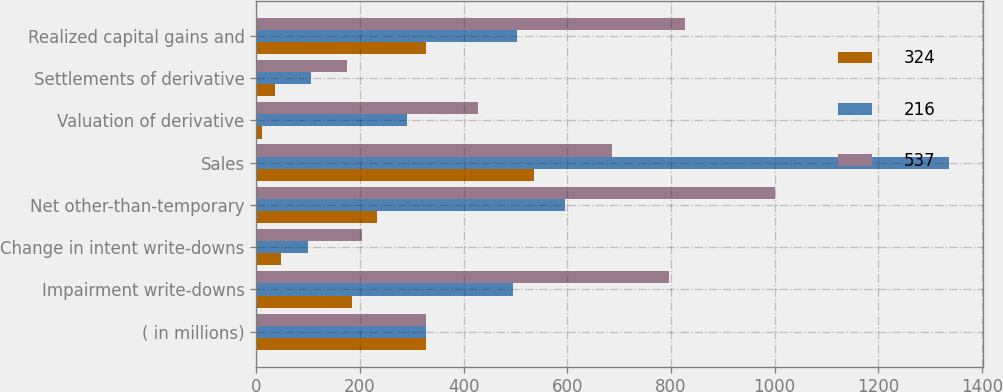Convert chart. <chart><loc_0><loc_0><loc_500><loc_500><stacked_bar_chart><ecel><fcel>( in millions)<fcel>Impairment write-downs<fcel>Change in intent write-downs<fcel>Net other-than-temporary<fcel>Sales<fcel>Valuation of derivative<fcel>Settlements of derivative<fcel>Realized capital gains and<nl><fcel>324<fcel>327<fcel>185<fcel>48<fcel>233<fcel>536<fcel>11<fcel>35<fcel>327<nl><fcel>216<fcel>327<fcel>496<fcel>100<fcel>596<fcel>1336<fcel>291<fcel>105<fcel>503<nl><fcel>537<fcel>327<fcel>797<fcel>204<fcel>1001<fcel>686<fcel>427<fcel>174<fcel>827<nl></chart> 